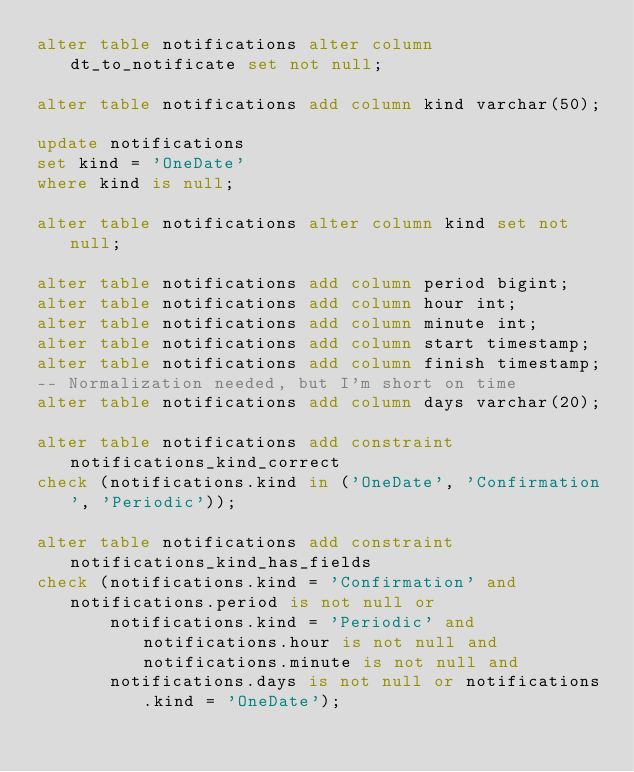<code> <loc_0><loc_0><loc_500><loc_500><_SQL_>alter table notifications alter column dt_to_notificate set not null;

alter table notifications add column kind varchar(50);

update notifications
set kind = 'OneDate'
where kind is null;

alter table notifications alter column kind set not null;

alter table notifications add column period bigint;
alter table notifications add column hour int;
alter table notifications add column minute int;
alter table notifications add column start timestamp;
alter table notifications add column finish timestamp;
-- Normalization needed, but I'm short on time
alter table notifications add column days varchar(20);

alter table notifications add constraint notifications_kind_correct
check (notifications.kind in ('OneDate', 'Confirmation', 'Periodic'));

alter table notifications add constraint notifications_kind_has_fields
check (notifications.kind = 'Confirmation' and notifications.period is not null or
       notifications.kind = 'Periodic' and notifications.hour is not null and notifications.minute is not null and
       notifications.days is not null or notifications.kind = 'OneDate');
</code> 